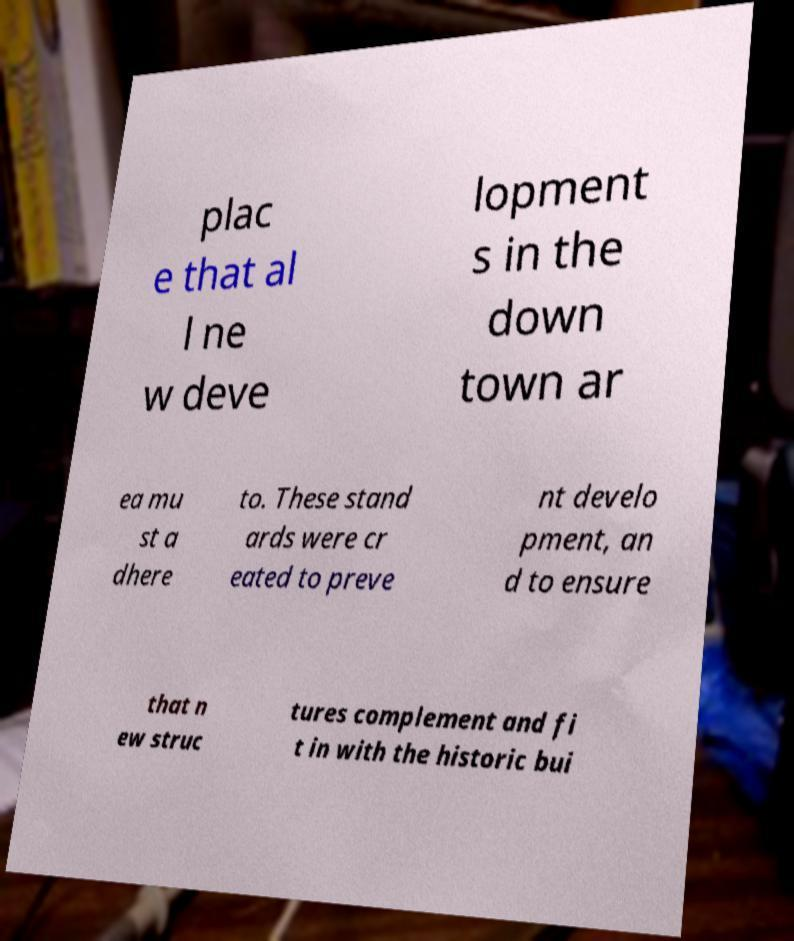For documentation purposes, I need the text within this image transcribed. Could you provide that? plac e that al l ne w deve lopment s in the down town ar ea mu st a dhere to. These stand ards were cr eated to preve nt develo pment, an d to ensure that n ew struc tures complement and fi t in with the historic bui 